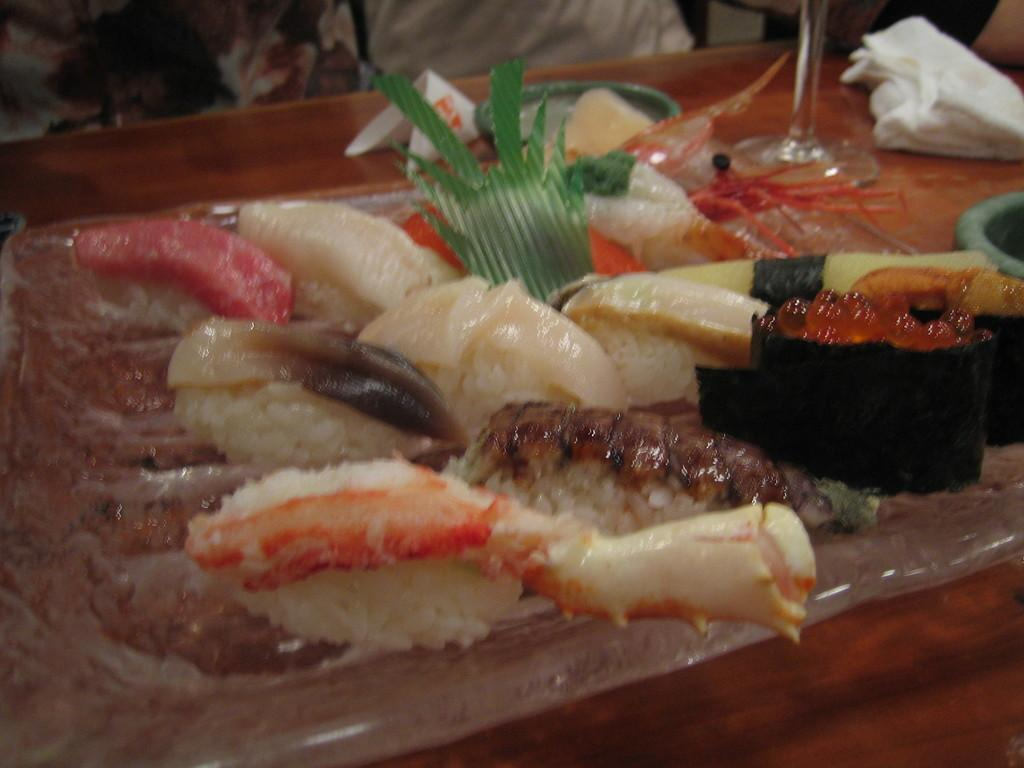What piece of furniture is present in the image? There is a table in the image. What is placed on the table? There is a glass, napkins, plates, a tray, and food placed on the table. What might be used for cleaning or wiping in the image? Napkins are present on the table for cleaning or wiping. What is the purpose of the tray on the table? The tray on the table might be used for holding or serving food. What type of property is visible in the image? There is no property visible in the image; it only shows a table with various items on it. 